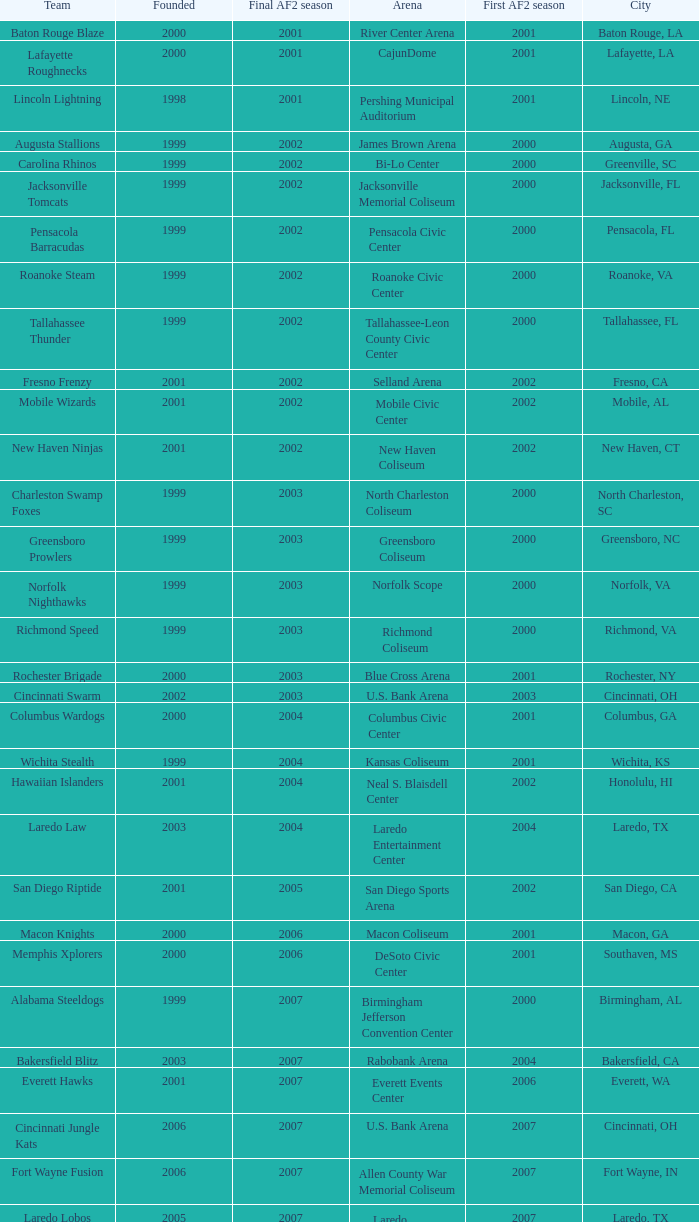What is the mean Founded number when the team is the Baton Rouge Blaze? 2000.0. 